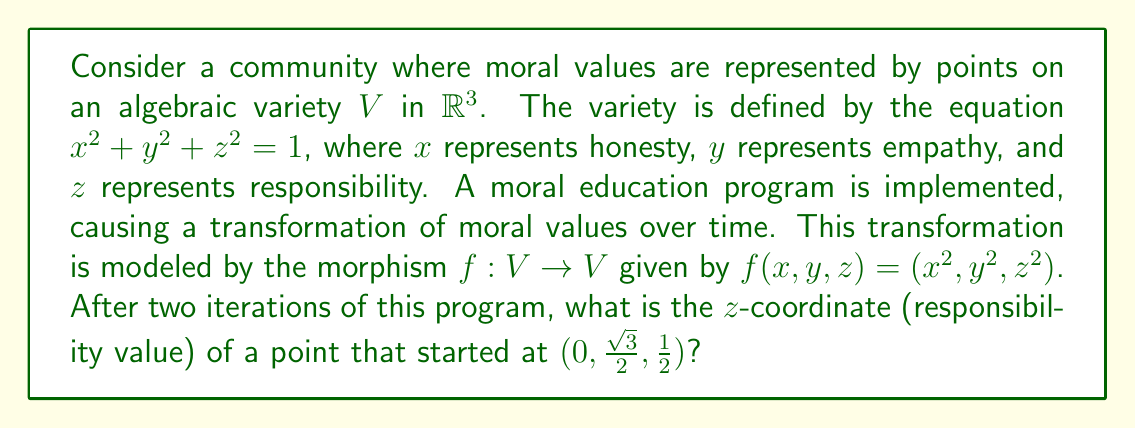Give your solution to this math problem. Let's approach this step-by-step:

1) We start with the point $P_0 = (0, \frac{\sqrt{3}}{2}, \frac{1}{2})$ on the variety $V$.

2) We need to apply the morphism $f$ twice to this point.

3) First iteration:
   $f(P_0) = f(0, \frac{\sqrt{3}}{2}, \frac{1}{2}) = (0^2, (\frac{\sqrt{3}}{2})^2, (\frac{1}{2})^2) = (0, \frac{3}{4}, \frac{1}{4})$
   Let's call this point $P_1 = (0, \frac{3}{4}, \frac{1}{4})$

4) Second iteration:
   $f(P_1) = f(0, \frac{3}{4}, \frac{1}{4}) = (0^2, (\frac{3}{4})^2, (\frac{1}{4})^2) = (0, \frac{9}{16}, \frac{1}{16})$
   Let's call this point $P_2 = (0, \frac{9}{16}, \frac{1}{16})$

5) The question asks for the $z$-coordinate of the final point, which is $\frac{1}{16}$.

Note: We don't need to verify if the points remain on the variety after each transformation, as this is guaranteed by the properties of morphisms between algebraic varieties.
Answer: $\frac{1}{16}$ 